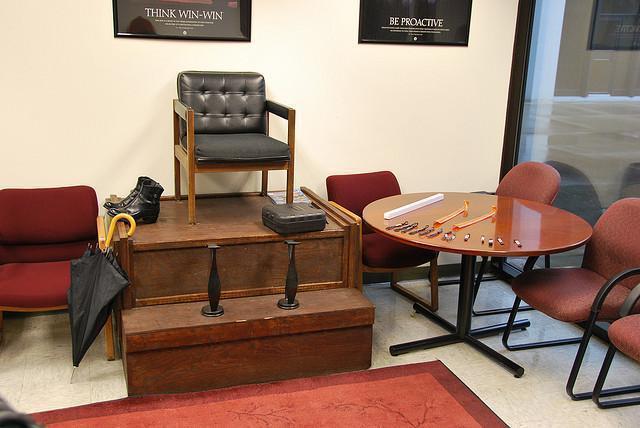What activity goes on in the chair on the platform?
Choose the correct response, then elucidate: 'Answer: answer
Rationale: rationale.'
Options: Shoe shining, beard shaving, haircuts, scalp massage. Answer: shoe shining.
Rationale: The chair is high up like "on a throne," shoes are to the side, and two metal bars where you place your feet so the person can shine the footwear. 